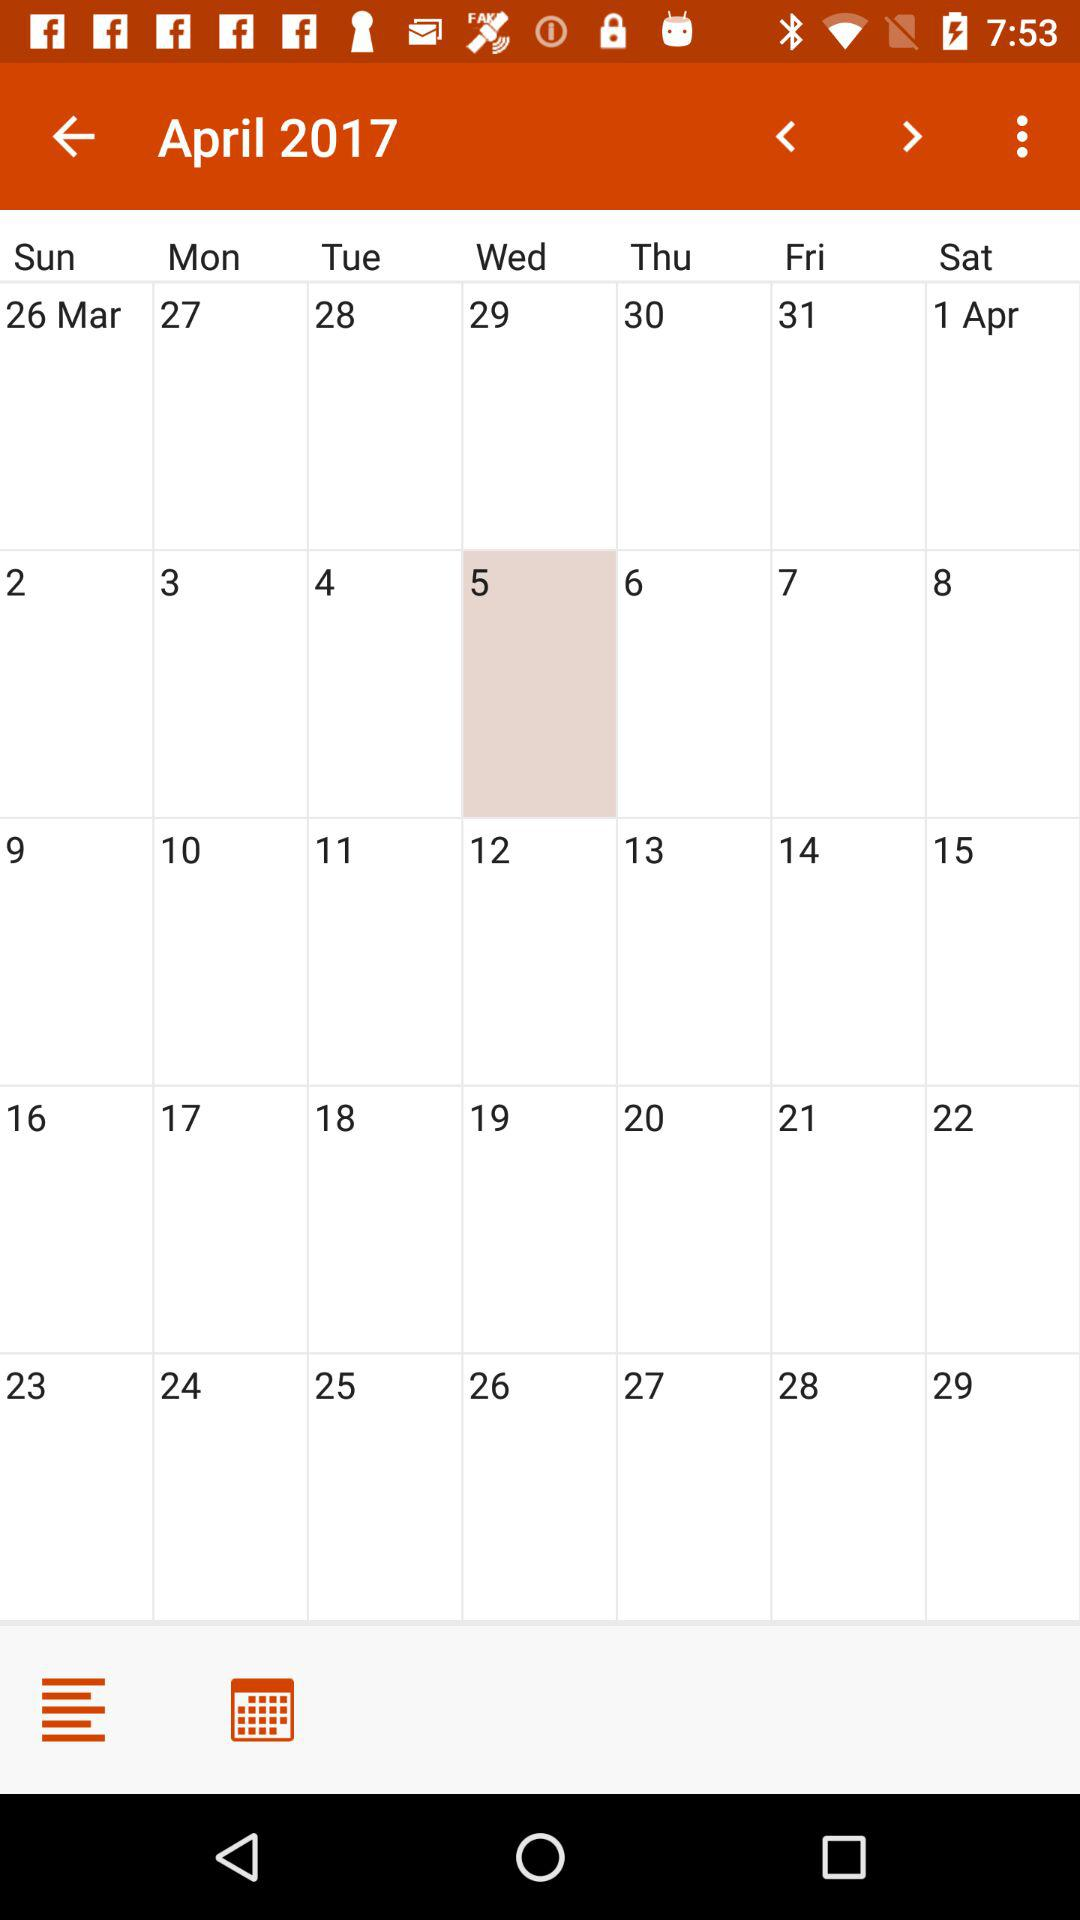What is the selected date? The selected date is Wednesday, April 5, 2017. 